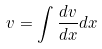Convert formula to latex. <formula><loc_0><loc_0><loc_500><loc_500>v = \int \frac { d v } { d x } d x</formula> 